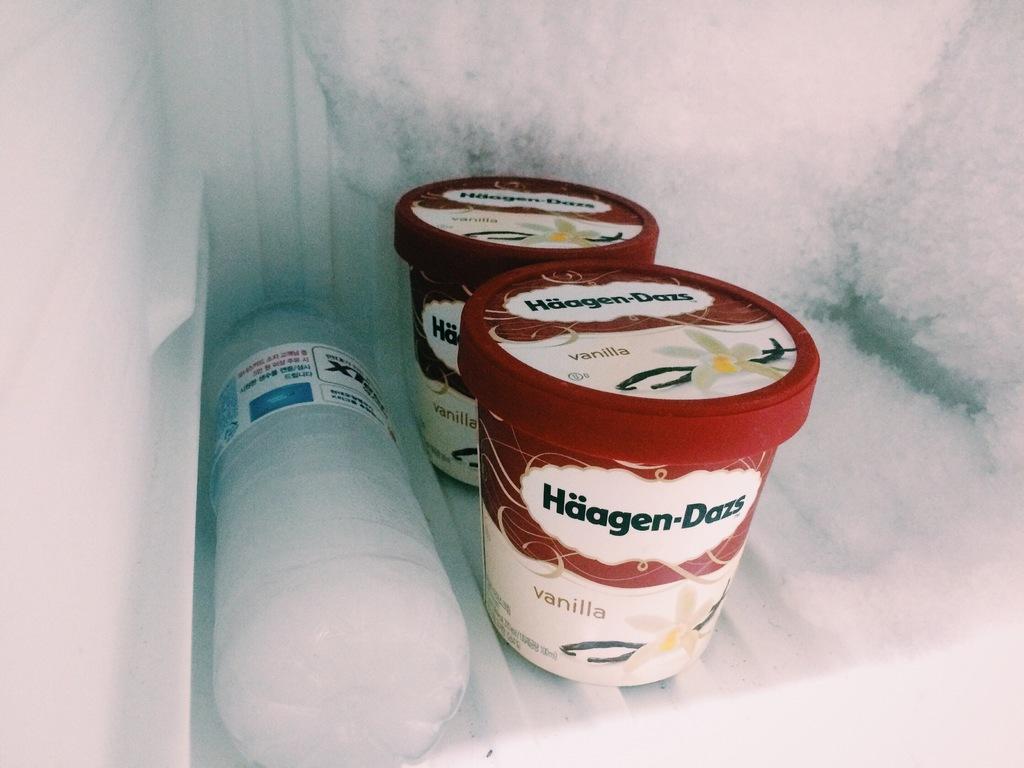Describe this image in one or two sentences. In this image we can see plastic containers and a disposal bottle inside the freezer. 